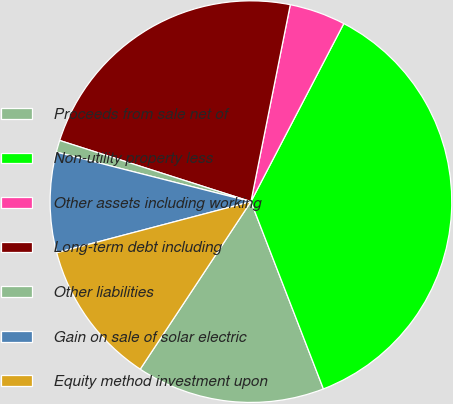<chart> <loc_0><loc_0><loc_500><loc_500><pie_chart><fcel>Proceeds from sale net of<fcel>Non-utility property less<fcel>Other assets including working<fcel>Long-term debt including<fcel>Other liabilities<fcel>Gain on sale of solar electric<fcel>Equity method investment upon<nl><fcel>15.17%<fcel>36.47%<fcel>4.51%<fcel>23.21%<fcel>0.96%<fcel>8.06%<fcel>11.61%<nl></chart> 